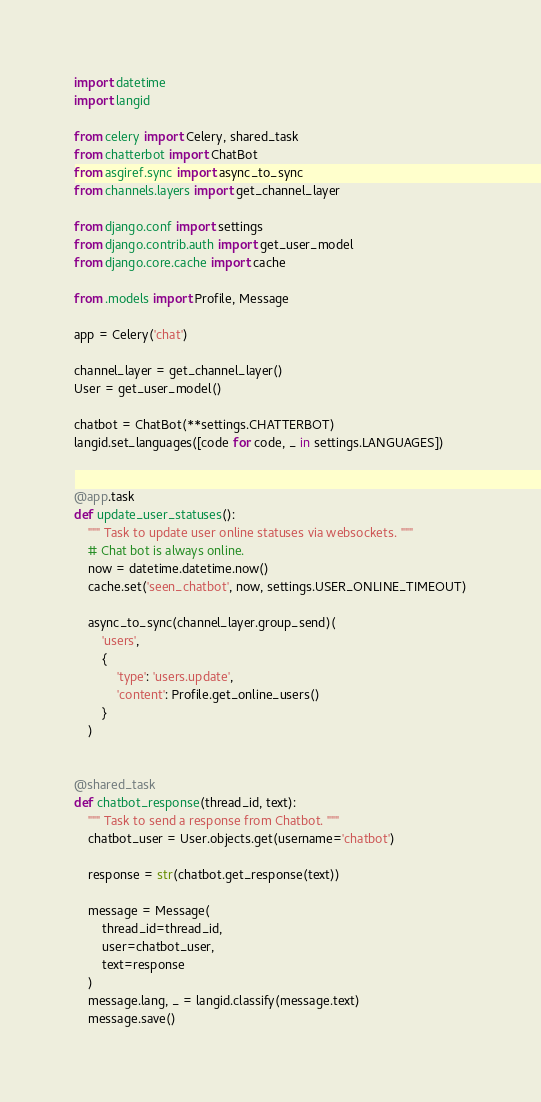Convert code to text. <code><loc_0><loc_0><loc_500><loc_500><_Python_>import datetime
import langid

from celery import Celery, shared_task
from chatterbot import ChatBot
from asgiref.sync import async_to_sync
from channels.layers import get_channel_layer

from django.conf import settings
from django.contrib.auth import get_user_model
from django.core.cache import cache

from .models import Profile, Message

app = Celery('chat')

channel_layer = get_channel_layer()
User = get_user_model()

chatbot = ChatBot(**settings.CHATTERBOT)
langid.set_languages([code for code, _ in settings.LANGUAGES])


@app.task
def update_user_statuses():
    """ Task to update user online statuses via websockets. """
    # Chat bot is always online.
    now = datetime.datetime.now()
    cache.set('seen_chatbot', now, settings.USER_ONLINE_TIMEOUT)

    async_to_sync(channel_layer.group_send)(
        'users',
        {
            'type': 'users.update',
            'content': Profile.get_online_users()
        }
    )


@shared_task
def chatbot_response(thread_id, text):
    """ Task to send a response from Chatbot. """
    chatbot_user = User.objects.get(username='chatbot')

    response = str(chatbot.get_response(text))

    message = Message(
        thread_id=thread_id,
        user=chatbot_user,
        text=response
    )
    message.lang, _ = langid.classify(message.text)
    message.save()
</code> 